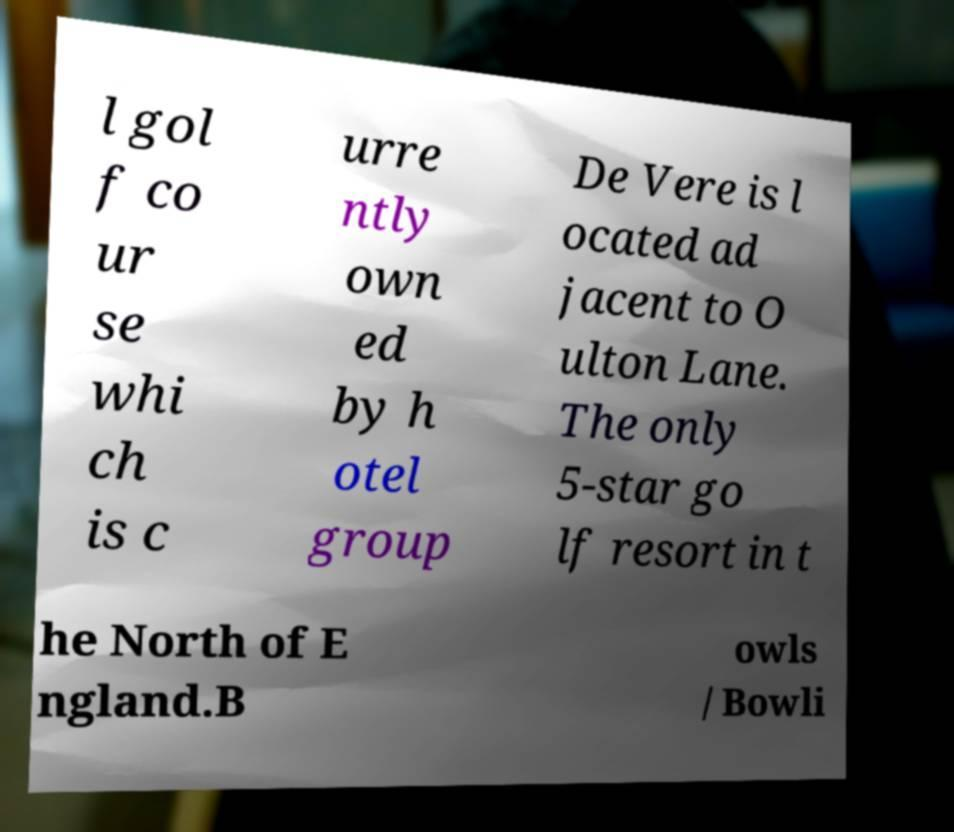Could you extract and type out the text from this image? l gol f co ur se whi ch is c urre ntly own ed by h otel group De Vere is l ocated ad jacent to O ulton Lane. The only 5-star go lf resort in t he North of E ngland.B owls / Bowli 